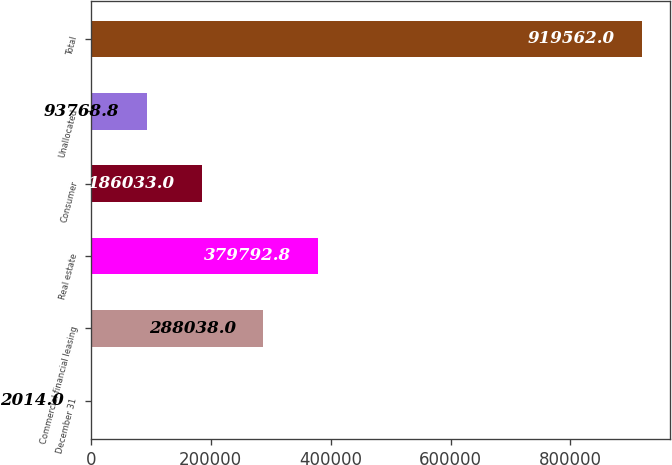Convert chart to OTSL. <chart><loc_0><loc_0><loc_500><loc_500><bar_chart><fcel>December 31<fcel>Commercial financial leasing<fcel>Real estate<fcel>Consumer<fcel>Unallocated<fcel>Total<nl><fcel>2014<fcel>288038<fcel>379793<fcel>186033<fcel>93768.8<fcel>919562<nl></chart> 